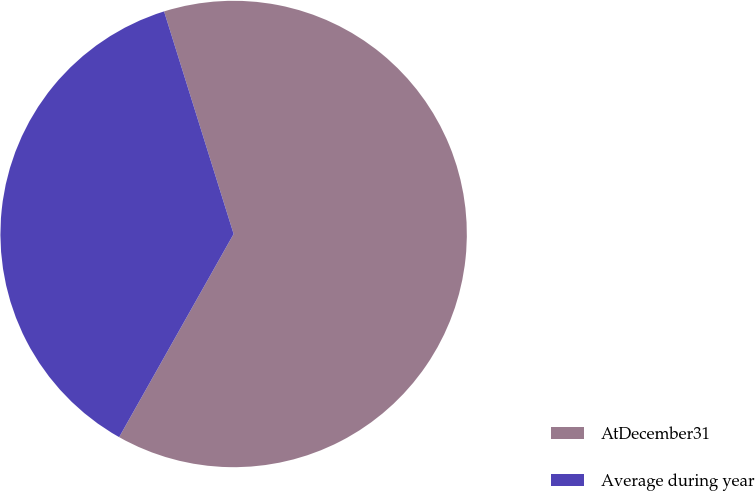Convert chart. <chart><loc_0><loc_0><loc_500><loc_500><pie_chart><fcel>AtDecember31<fcel>Average during year<nl><fcel>62.99%<fcel>37.01%<nl></chart> 